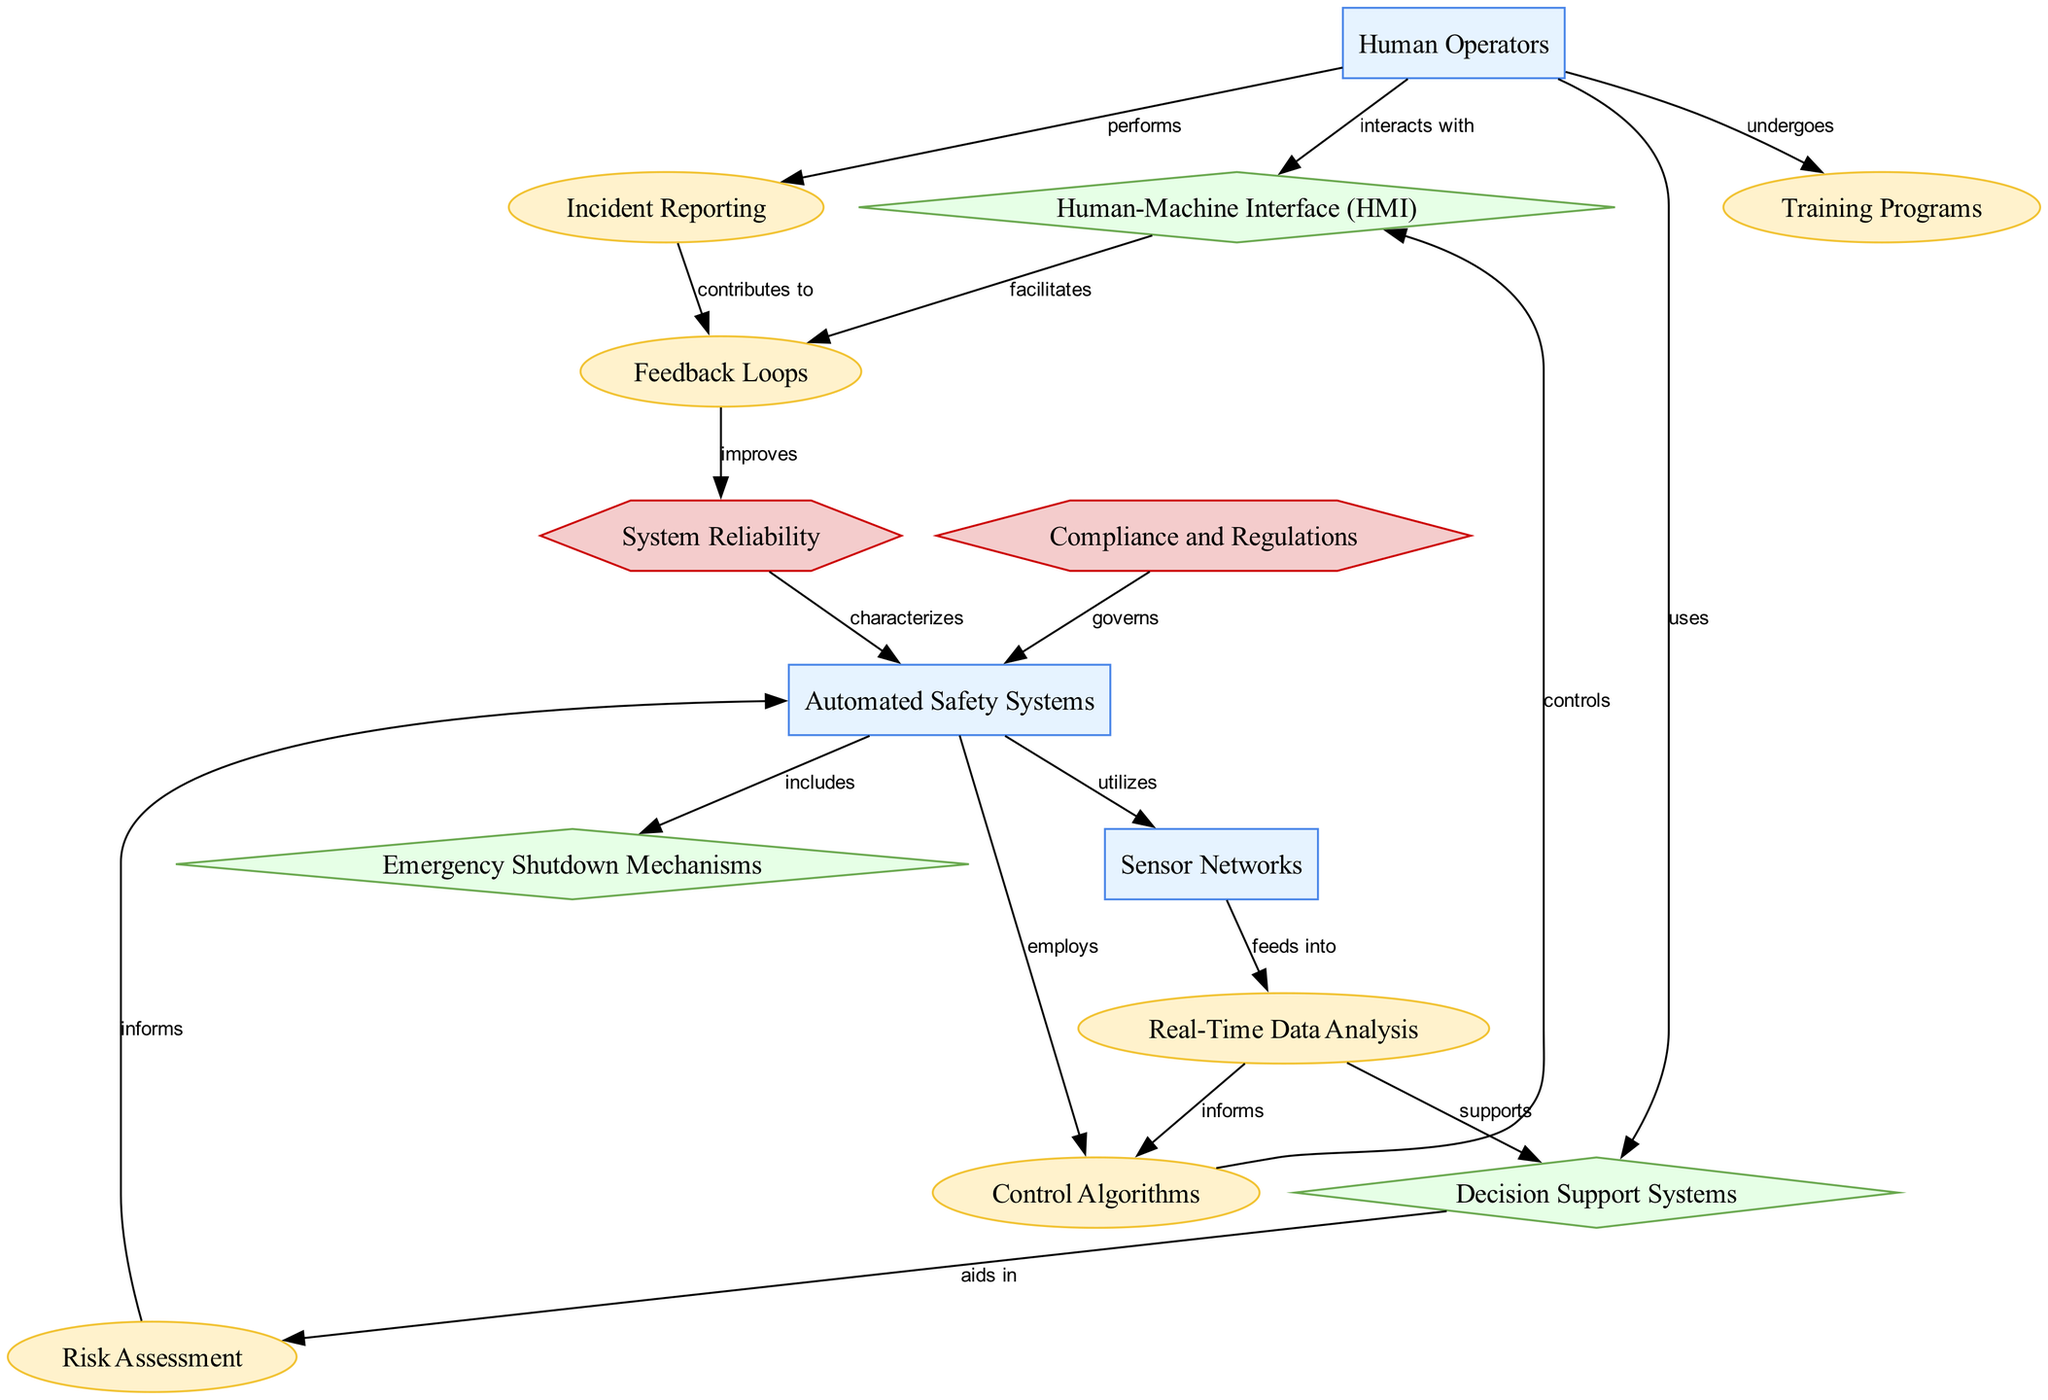What is the role of Human Operators in the system? Human Operators monitor and control automated systems while interacting with them. They undergo training programs, use decision support systems, and perform incident reporting, which highlights their multifaceted role in the safety and functionality of automated environments.
Answer: Individuals monitoring and controlling automated systems How many process elements are in the diagram? The diagram contains seven process elements: Real-Time Data Analysis, Control Algorithms, Training Programs, Feedback Loops, Risk Assessment, Incident Reporting, and the interactions between them.
Answer: Seven What component is responsible for emergency situations? The component designed specifically for handling emergency situations and safely shutting down operations is the Emergency Shutdown Mechanisms. This component acts autonomously to prevent accidents and manage anomalies when detected.
Answer: Emergency Shutdown Mechanisms Which component aids Human Operators in decision-making? The component that assists human operators in making informed decisions is the Decision Support Systems. It provides relevant data and analysis that help operators evaluate scenarios and make choices under the operational conditions.
Answer: Decision Support Systems How do Sensor Networks and Real-Time Data Analysis relate? Sensor Networks feed into Real-Time Data Analysis. This means that the data collected from various sensors is used to conduct analyses in real-time, allowing for immediate responses and adaptations in automated systems.
Answer: Feeds into How does Compliance and Regulations impact Automated Safety Systems? Compliance and Regulations govern the use and implementation of Automated Safety Systems. They set the legal and regulatory frameworks that guide how these systems must operate to ensure safety and efficiency in industrial environments.
Answer: Governs What is the input for Risk Assessment? The input for Risk Assessment is primarily related to identifying and evaluating risks associated with industrial operations, which includes data from incident reporting and system behaviors. These inputs are crucial for understanding potential threats within the automated systems.
Answer: Identifying and evaluating risks What do Feedback Loops contribute to? Feedback Loops contribute to improving System Reliability. They create a cyclic process by which outputs are returned as inputs for continuous improvement and correction, enhancing the ability of automated safety systems to function reliably over time.
Answer: Improves 